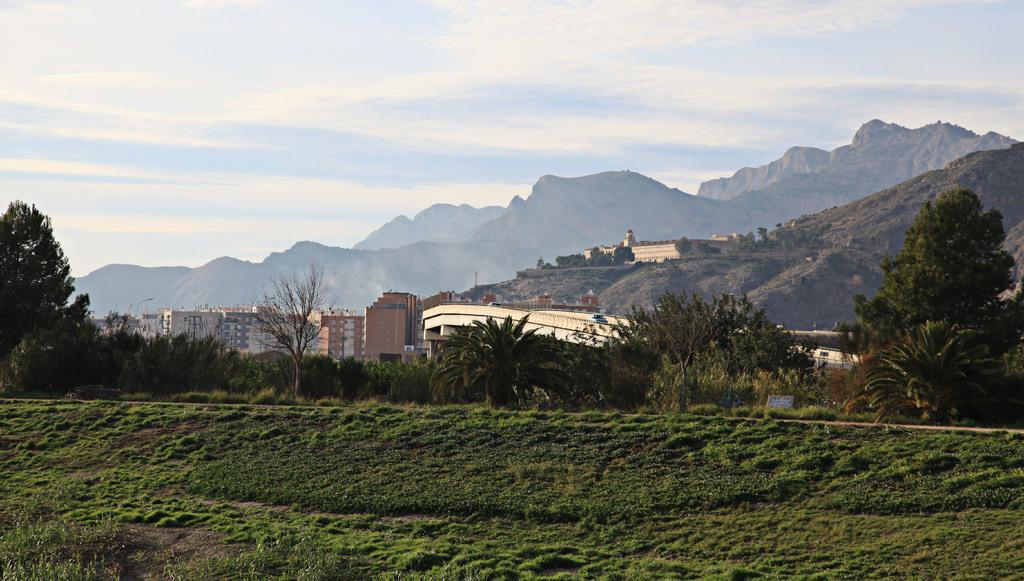What type of vegetation is present in the image? There is grass, trees, and plants in the image. What type of structures can be seen in the image? There are buildings in the image. What is the board in the image used for? The purpose of the board in the image is not specified, but it could be used for displaying information or as a sign. What is the natural feature visible in the image? There is a mountain in the image. What is visible at the top of the image? The sky is visible at the top of the image. What book is being advertised on the board in the image? There is no book or advertisement present on the board in the image. What is the desire of the mountain in the image? The mountain in the image is an inanimate object and does not have desires. 